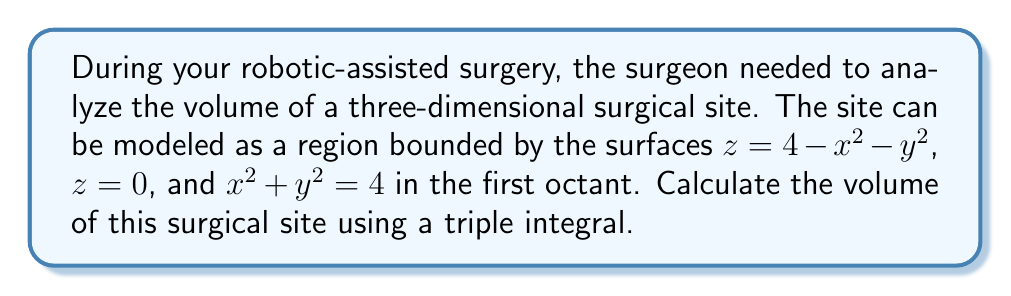Show me your answer to this math problem. To solve this problem, we'll use a triple integral in cylindrical coordinates. Here's the step-by-step solution:

1) First, let's visualize the region. It's bounded by a paraboloid $z = 4 - x^2 - y^2$ from above, the xy-plane $z = 0$ from below, and the cylinder $x^2 + y^2 = 4$ on the sides, all in the first octant.

2) In cylindrical coordinates:
   $x = r\cos\theta$
   $y = r\sin\theta$
   $z = z$

3) The bounds of the region in cylindrical coordinates are:
   $0 \leq r \leq 2$ (from $x^2 + y^2 = 4$)
   $0 \leq \theta \leq \frac{\pi}{2}$ (first quadrant in xy-plane)
   $0 \leq z \leq 4 - r^2$ (from $z = 4 - x^2 - y^2$)

4) The volume integral in cylindrical coordinates is:

   $$V = \int_0^{\frac{\pi}{2}} \int_0^2 \int_0^{4-r^2} r \, dz \, dr \, d\theta$$

5) Let's solve the integral from inside out:

   $$V = \int_0^{\frac{\pi}{2}} \int_0^2 r(4-r^2) \, dr \, d\theta$$

6) Integrate with respect to r:

   $$V = \int_0^{\frac{\pi}{2}} \left[2r^2 - \frac{r^4}{4}\right]_0^2 \, d\theta$$

7) Evaluate the inner integral:

   $$V = \int_0^{\frac{\pi}{2}} \left(8 - 4\right) \, d\theta = \int_0^{\frac{\pi}{2}} 4 \, d\theta$$

8) Finally, integrate with respect to θ:

   $$V = \left[4\theta\right]_0^{\frac{\pi}{2}} = 4 \cdot \frac{\pi}{2} = 2\pi$$

Thus, the volume of the surgical site is $2\pi$ cubic units.
Answer: $2\pi$ cubic units 